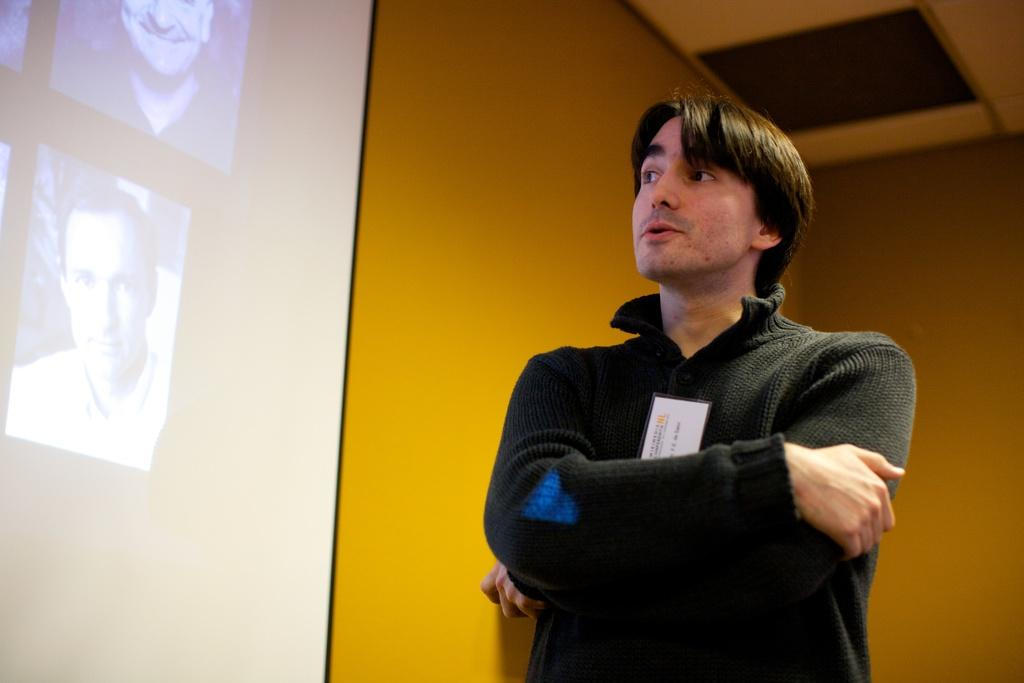What is the main subject of the image? There is a person standing in the image. What can be seen on the wall in the image? There is a presentation screen on the wall in the image. What type of clouds can be seen in the image? There are no clouds visible in the image; it features a person standing and a presentation screen on the wall. Is there an island present in the image? There is no island present in the image. 